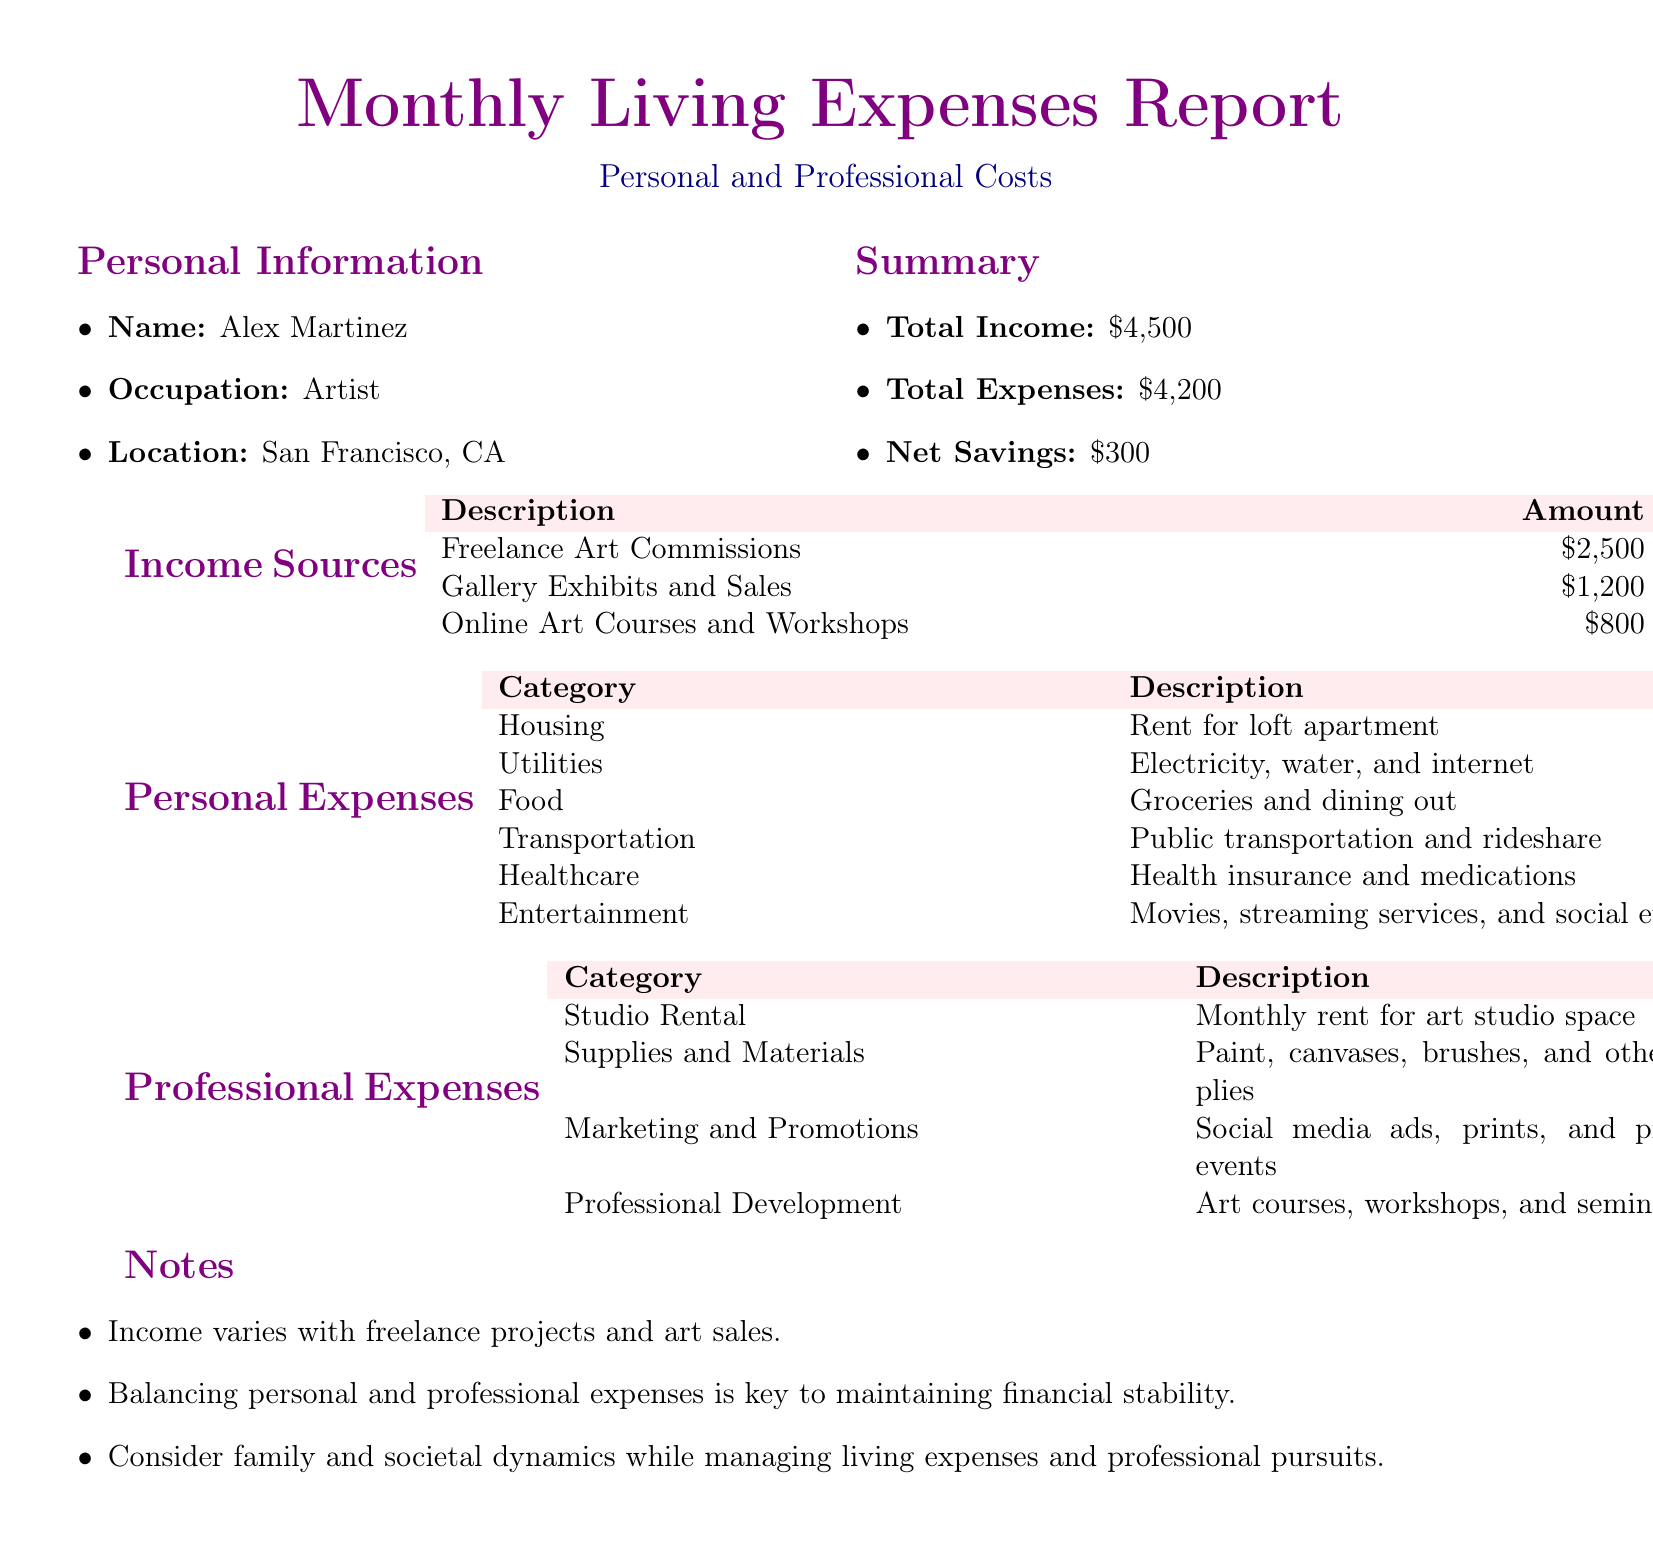What is the name of the individual? The name of the individual is provided in the personal information section of the document.
Answer: Alex Martinez What is the total income? The total income is listed in the summary section of the document.
Answer: $4,500 How much is spent on rent for the loft apartment? The rent amount is specified in the personal expenses section under housing.
Answer: $1,800 What are the total professional expenses? The document provides separate categories for professional expenses, which need to be summed up to get the total.
Answer: $1,250 Which income source generates the most revenue? The income sources are listed with their amounts, indicating which contributes the most.
Answer: Freelance Art Commissions What is the amount spent on healthcare? The document specifies the expense amount for healthcare under personal expenses.
Answer: $250 How much is allocated for marketing and promotions? The professional expenses section lists the marketing and promotions expense.
Answer: $150 What is the net savings? The net savings is the difference between total income and total expenses, mentioned in the summary.
Answer: $300 What is the expense for supplies and materials? The document mentions the specific cost associated with supplies and materials in professional expenses.
Answer: $300 